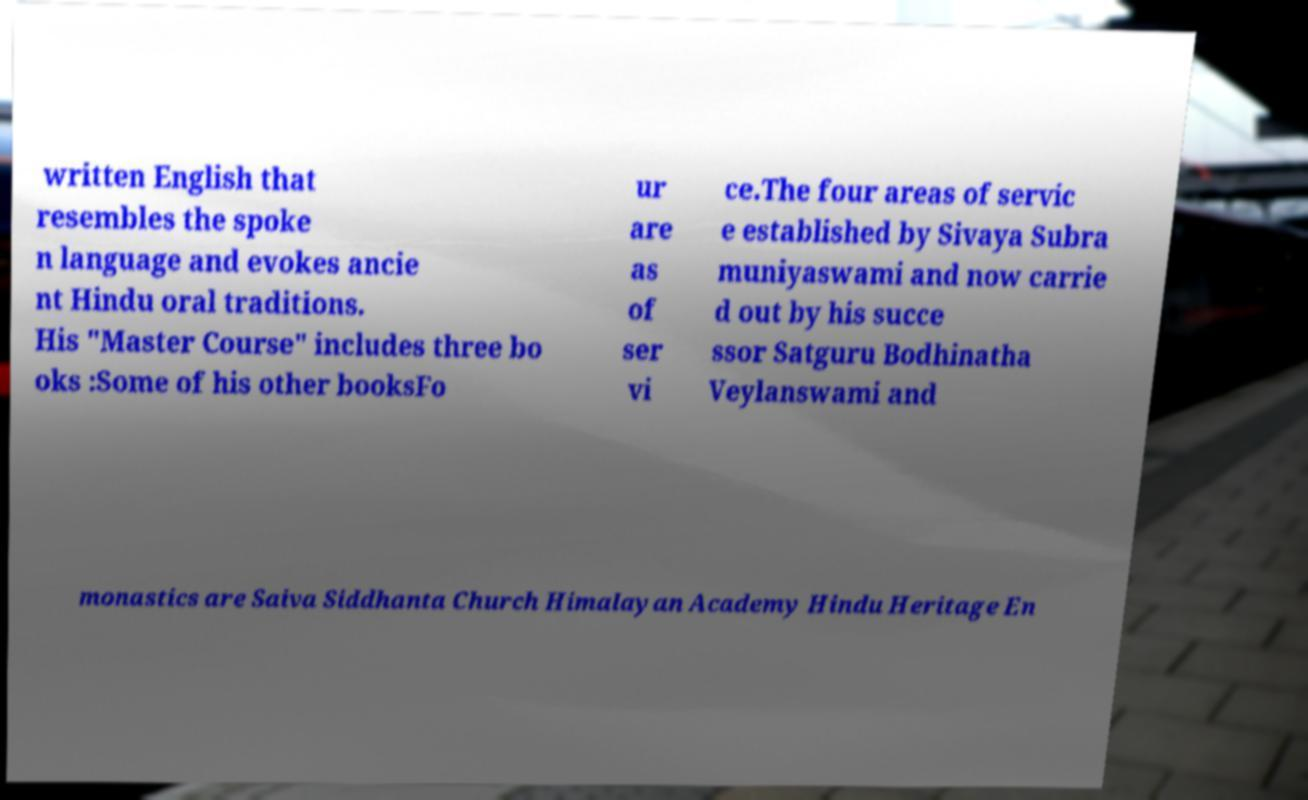Could you extract and type out the text from this image? written English that resembles the spoke n language and evokes ancie nt Hindu oral traditions. His "Master Course" includes three bo oks :Some of his other booksFo ur are as of ser vi ce.The four areas of servic e established by Sivaya Subra muniyaswami and now carrie d out by his succe ssor Satguru Bodhinatha Veylanswami and monastics are Saiva Siddhanta Church Himalayan Academy Hindu Heritage En 